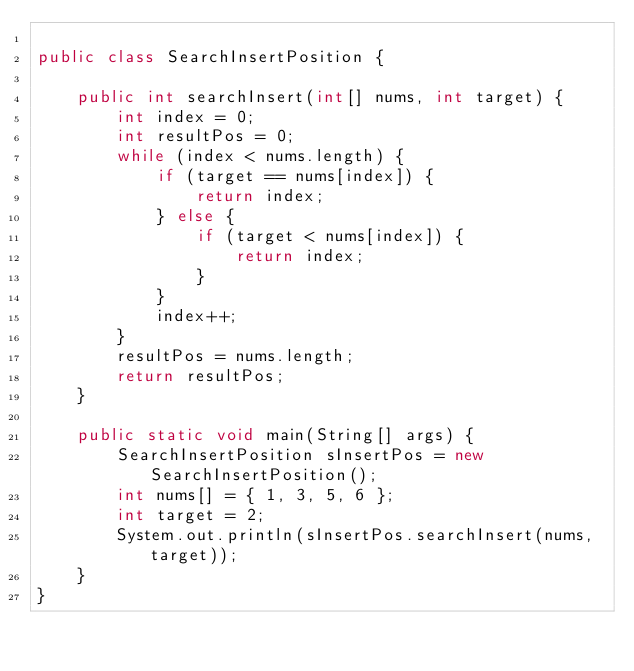<code> <loc_0><loc_0><loc_500><loc_500><_Java_>
public class SearchInsertPosition {

	public int searchInsert(int[] nums, int target) {
		int index = 0;
		int resultPos = 0;
		while (index < nums.length) {
			if (target == nums[index]) {
				return index;
			} else {
				if (target < nums[index]) {
					return index;
				}
			}
			index++;
		}
		resultPos = nums.length;
		return resultPos;
	}

	public static void main(String[] args) {
		SearchInsertPosition sInsertPos = new SearchInsertPosition();
		int nums[] = { 1, 3, 5, 6 };
		int target = 2;
		System.out.println(sInsertPos.searchInsert(nums, target));
	}
}
</code> 